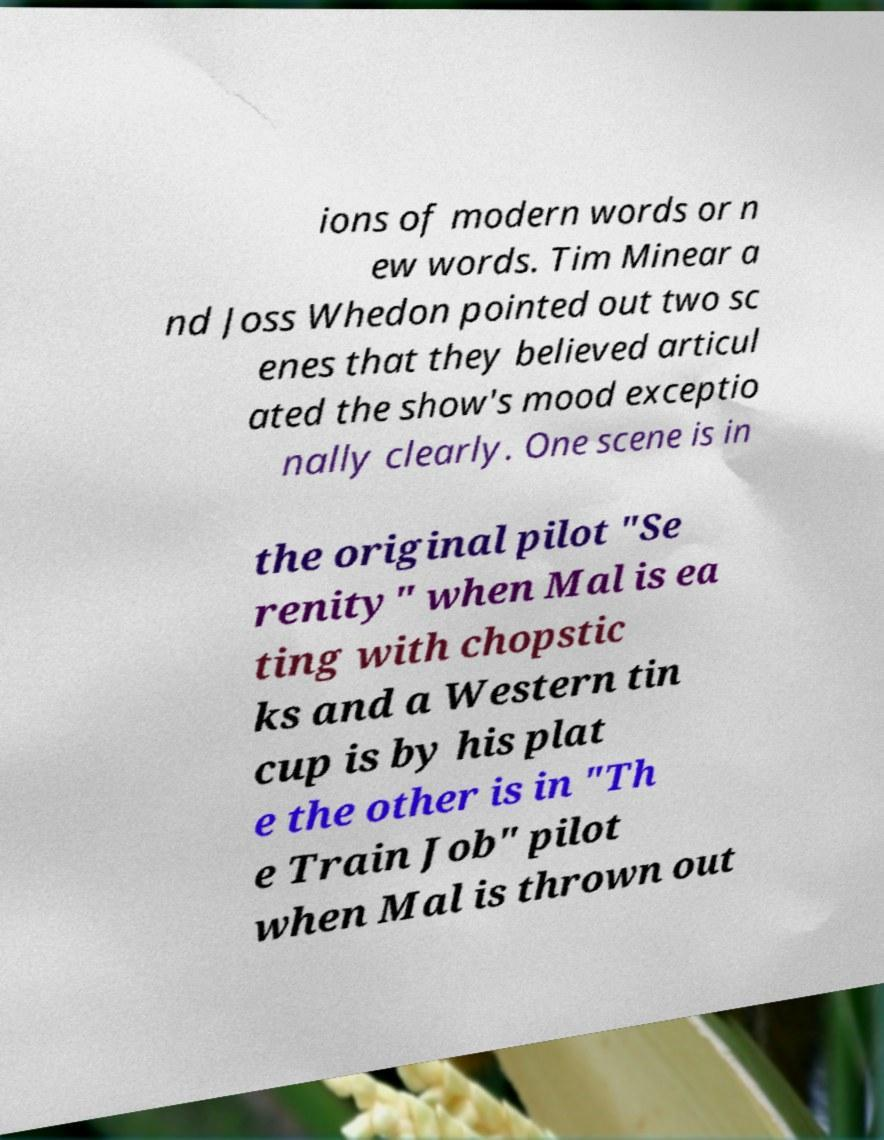What messages or text are displayed in this image? I need them in a readable, typed format. ions of modern words or n ew words. Tim Minear a nd Joss Whedon pointed out two sc enes that they believed articul ated the show's mood exceptio nally clearly. One scene is in the original pilot "Se renity" when Mal is ea ting with chopstic ks and a Western tin cup is by his plat e the other is in "Th e Train Job" pilot when Mal is thrown out 